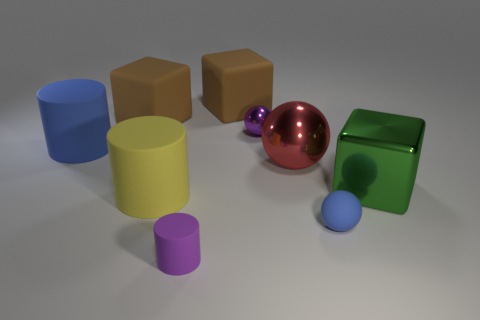What number of objects are large rubber things right of the big blue thing or tiny cylinders?
Your response must be concise. 4. There is a large block that is right of the tiny purple metal sphere; is its color the same as the big metal sphere?
Offer a very short reply. No. There is a blue rubber object that is behind the large green object; what is its size?
Offer a terse response. Large. There is a small purple object that is behind the blue matte thing that is behind the large green thing; what is its shape?
Keep it short and to the point. Sphere. The tiny rubber object that is the same shape as the small metal object is what color?
Offer a very short reply. Blue. There is a blue ball in front of the blue cylinder; does it have the same size as the yellow matte cylinder?
Your answer should be very brief. No. There is a thing that is the same color as the tiny rubber cylinder; what is its shape?
Keep it short and to the point. Sphere. What number of small green cylinders are the same material as the red thing?
Offer a very short reply. 0. What is the brown thing that is on the right side of the brown block left of the brown object that is to the right of the small purple matte thing made of?
Offer a terse response. Rubber. What color is the tiny rubber object on the left side of the tiny ball in front of the big blue cylinder?
Your answer should be compact. Purple. 